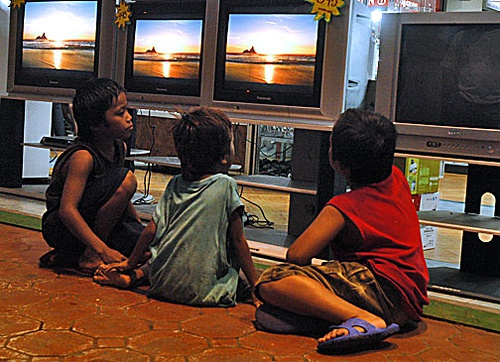Describe the objects in this image and their specific colors. I can see people in lightblue, black, brown, and maroon tones, people in lightblue, black, gray, maroon, and darkgreen tones, people in lightblue, black, maroon, and brown tones, tv in lightblue, black, and gray tones, and tv in lightblue, black, white, and brown tones in this image. 